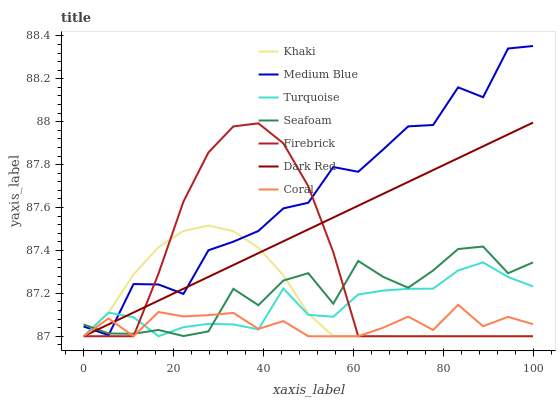Does Coral have the minimum area under the curve?
Answer yes or no. Yes. Does Medium Blue have the maximum area under the curve?
Answer yes or no. Yes. Does Khaki have the minimum area under the curve?
Answer yes or no. No. Does Khaki have the maximum area under the curve?
Answer yes or no. No. Is Dark Red the smoothest?
Answer yes or no. Yes. Is Medium Blue the roughest?
Answer yes or no. Yes. Is Khaki the smoothest?
Answer yes or no. No. Is Khaki the roughest?
Answer yes or no. No. Does Turquoise have the lowest value?
Answer yes or no. Yes. Does Medium Blue have the lowest value?
Answer yes or no. No. Does Medium Blue have the highest value?
Answer yes or no. Yes. Does Khaki have the highest value?
Answer yes or no. No. Does Firebrick intersect Khaki?
Answer yes or no. Yes. Is Firebrick less than Khaki?
Answer yes or no. No. Is Firebrick greater than Khaki?
Answer yes or no. No. 